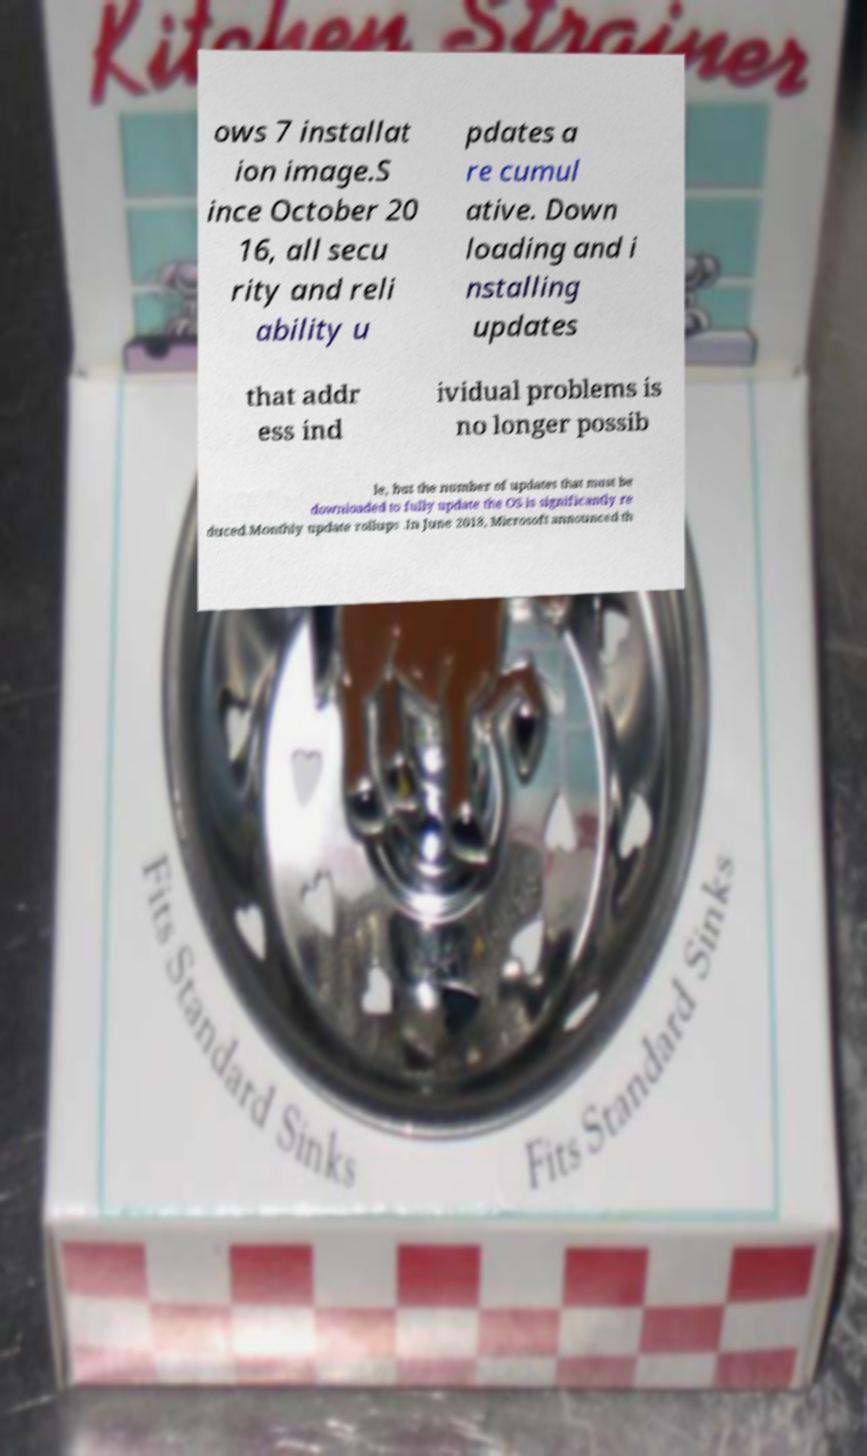Could you extract and type out the text from this image? ows 7 installat ion image.S ince October 20 16, all secu rity and reli ability u pdates a re cumul ative. Down loading and i nstalling updates that addr ess ind ividual problems is no longer possib le, but the number of updates that must be downloaded to fully update the OS is significantly re duced.Monthly update rollups .In June 2018, Microsoft announced th 